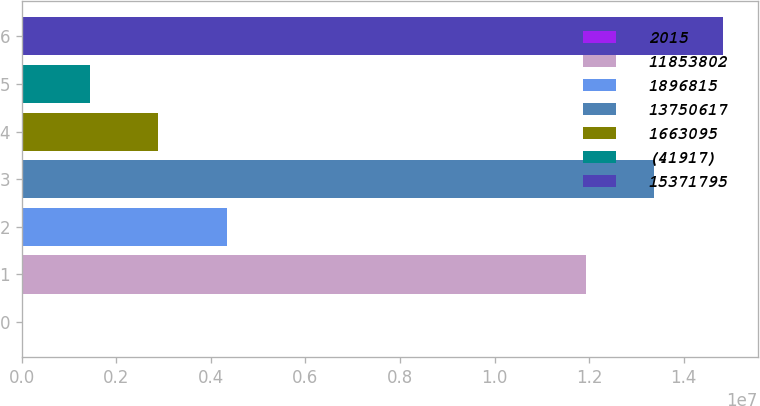<chart> <loc_0><loc_0><loc_500><loc_500><bar_chart><fcel>2015<fcel>11853802<fcel>1896815<fcel>13750617<fcel>1663095<fcel>(41917)<fcel>15371795<nl><fcel>2014<fcel>1.19336e+07<fcel>4.33387e+06<fcel>1.33775e+07<fcel>2.88992e+06<fcel>1.44597e+06<fcel>1.48215e+07<nl></chart> 